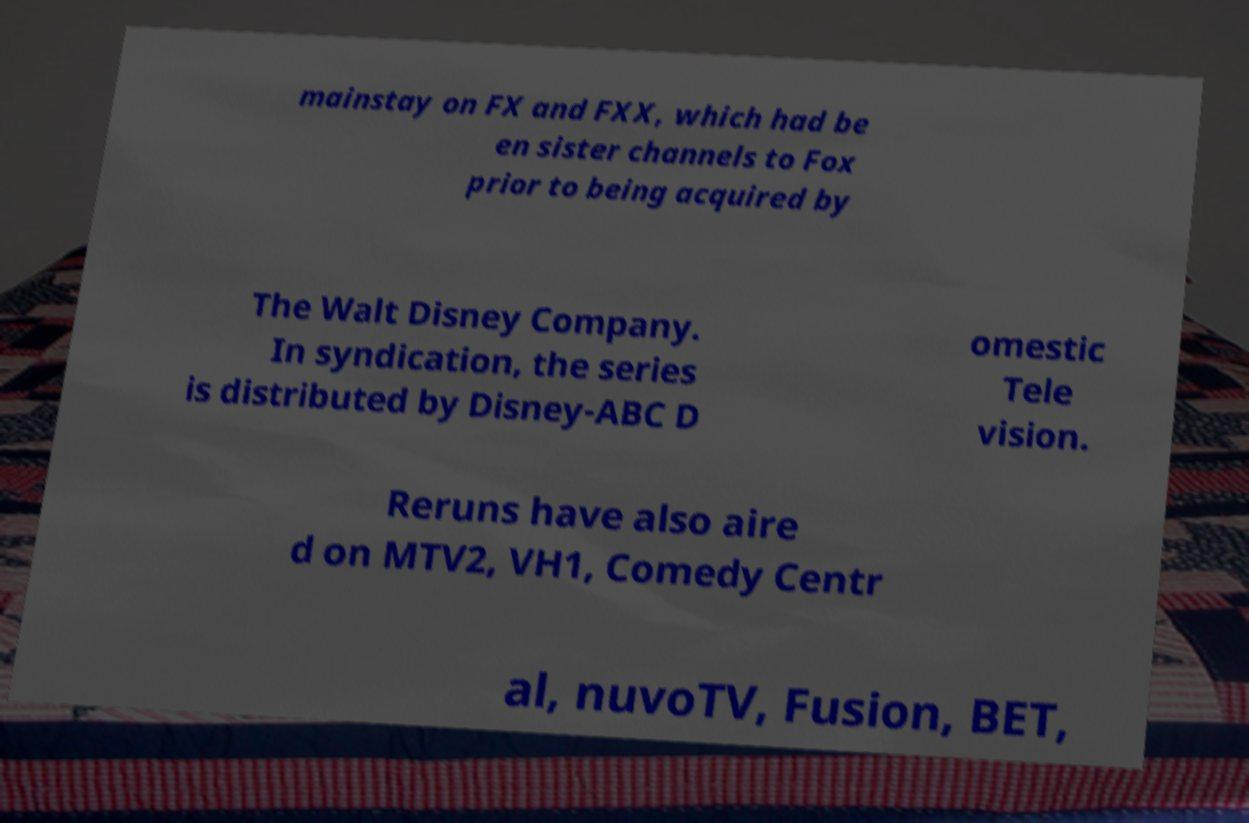Could you extract and type out the text from this image? mainstay on FX and FXX, which had be en sister channels to Fox prior to being acquired by The Walt Disney Company. In syndication, the series is distributed by Disney-ABC D omestic Tele vision. Reruns have also aire d on MTV2, VH1, Comedy Centr al, nuvoTV, Fusion, BET, 